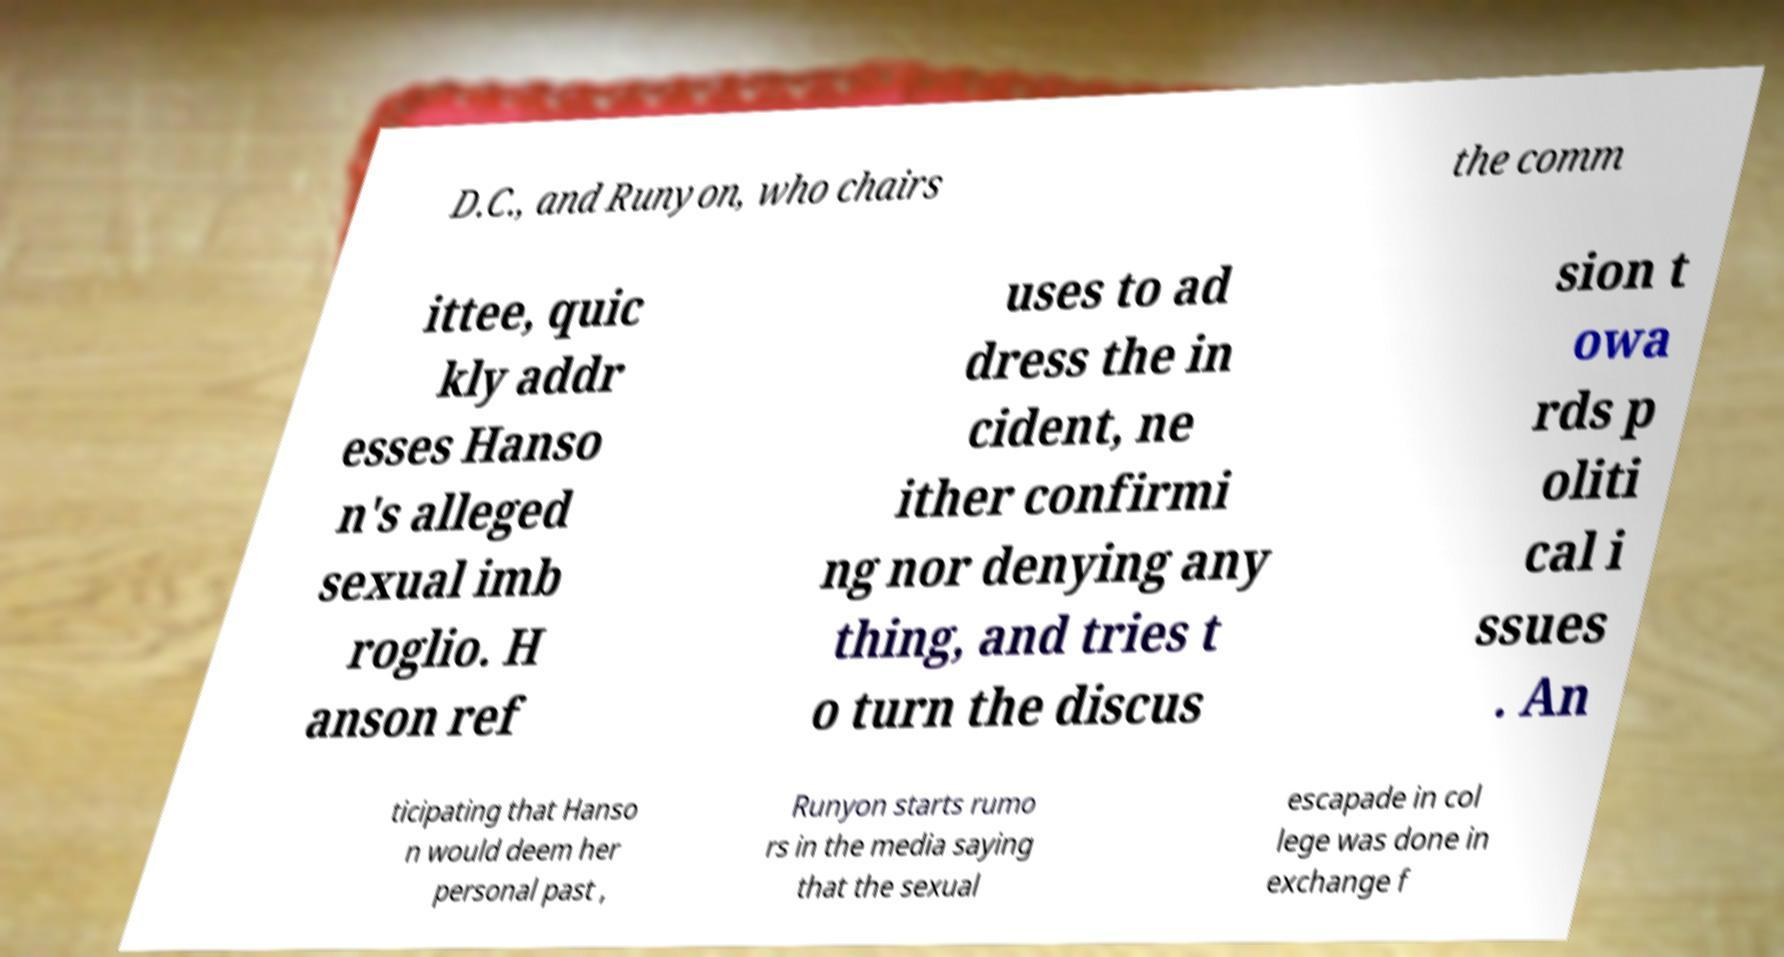Please identify and transcribe the text found in this image. D.C., and Runyon, who chairs the comm ittee, quic kly addr esses Hanso n's alleged sexual imb roglio. H anson ref uses to ad dress the in cident, ne ither confirmi ng nor denying any thing, and tries t o turn the discus sion t owa rds p oliti cal i ssues . An ticipating that Hanso n would deem her personal past , Runyon starts rumo rs in the media saying that the sexual escapade in col lege was done in exchange f 